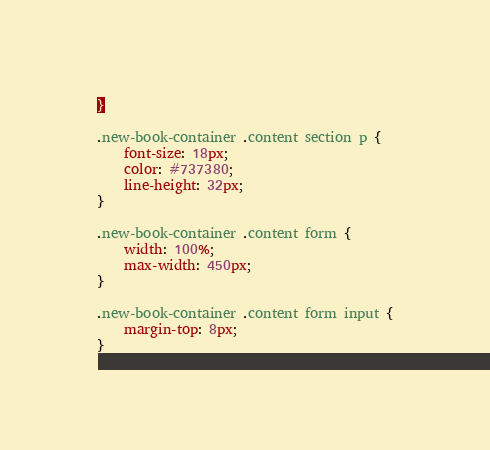Convert code to text. <code><loc_0><loc_0><loc_500><loc_500><_CSS_>}

.new-book-container .content section p {
    font-size: 18px;
    color: #737380;
    line-height: 32px;
}

.new-book-container .content form {
    width: 100%;
    max-width: 450px;
}

.new-book-container .content form input {
    margin-top: 8px;
}</code> 